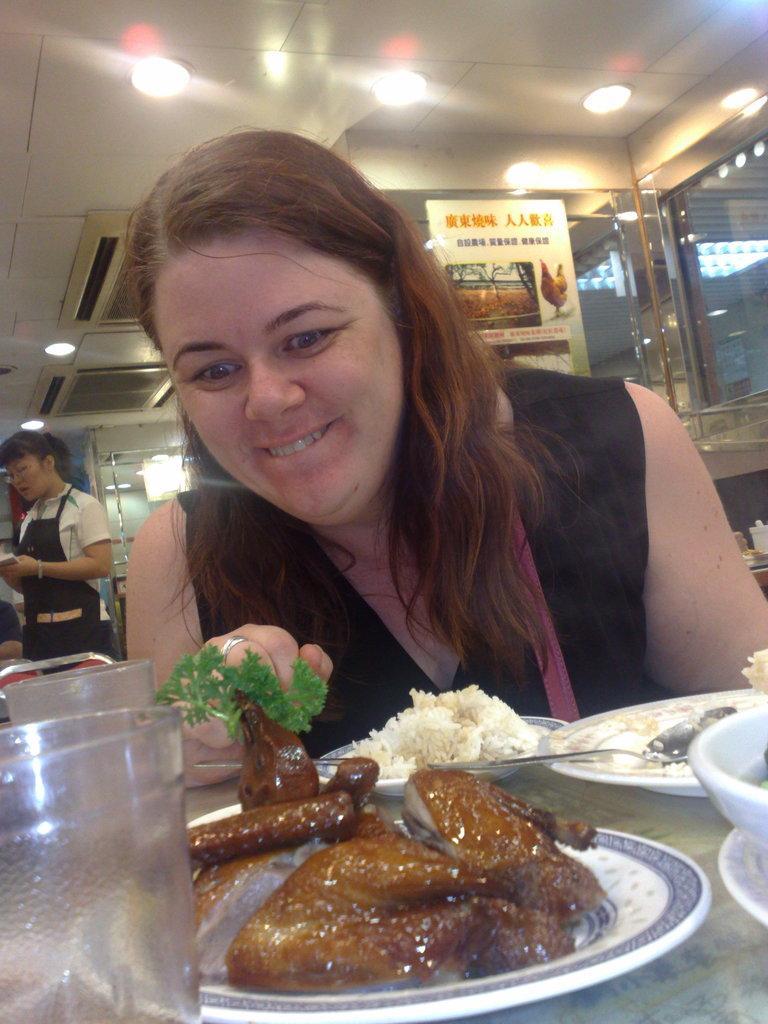Please provide a concise description of this image. In the foreground of the image there are food items on the plate. There is a table. There is a glass. There is a lady. At the top of the image there is ceiling with lights. There is a glass. There is a poster on the glass. There is a lady standing to the left side of the image. 